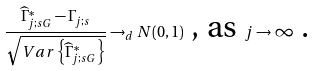Convert formula to latex. <formula><loc_0><loc_0><loc_500><loc_500>\frac { \widehat { \Gamma } _ { j ; s G } ^ { \ast } - \Gamma _ { j ; s } } { \sqrt { V a r \left \{ \widehat { \Gamma } _ { j ; s G } ^ { \ast } \right \} } } \rightarrow _ { d } N ( 0 , 1 ) \text { , as } j \rightarrow \infty \text { .}</formula> 